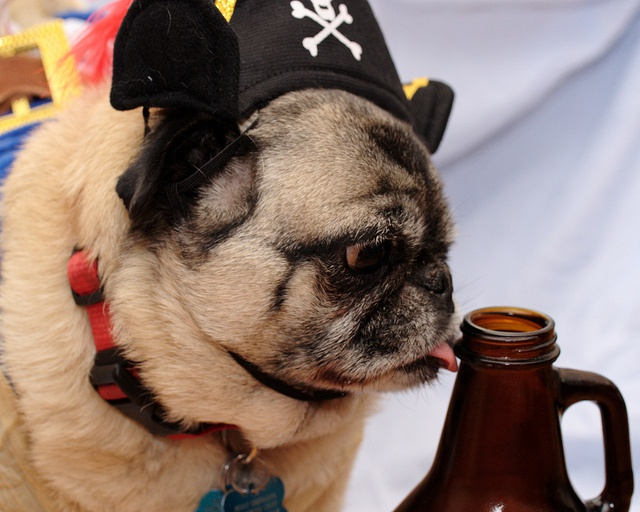Describe the objects in this image and their specific colors. I can see dog in pink, black, tan, and gray tones and bottle in pink, black, maroon, lavender, and gray tones in this image. 